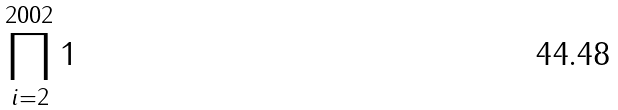Convert formula to latex. <formula><loc_0><loc_0><loc_500><loc_500>\prod _ { i = 2 } ^ { 2 0 0 2 } 1</formula> 